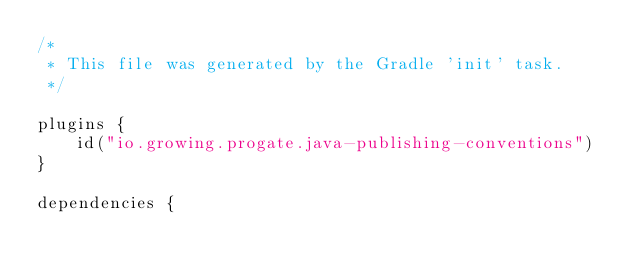<code> <loc_0><loc_0><loc_500><loc_500><_Kotlin_>/*
 * This file was generated by the Gradle 'init' task.
 */

plugins {
    id("io.growing.progate.java-publishing-conventions")
}

dependencies {
</code> 